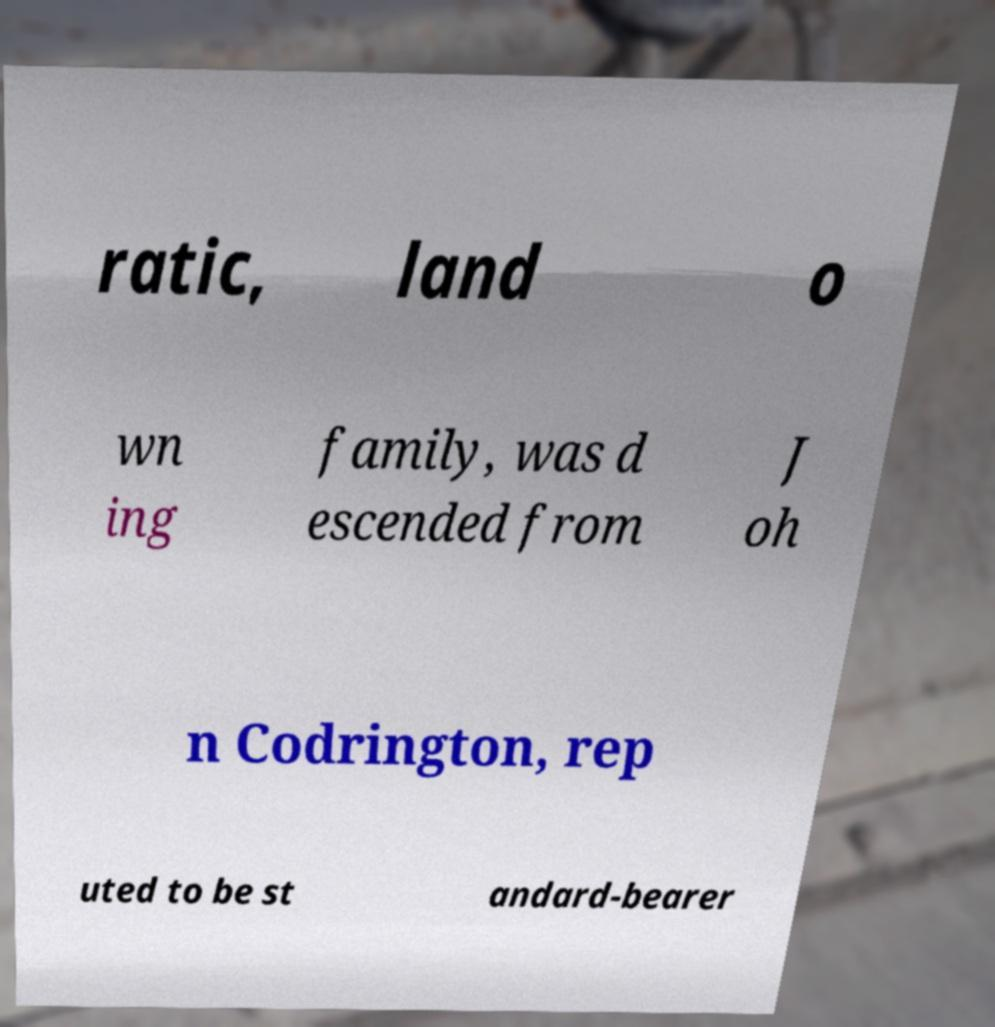What messages or text are displayed in this image? I need them in a readable, typed format. ratic, land o wn ing family, was d escended from J oh n Codrington, rep uted to be st andard-bearer 